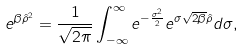<formula> <loc_0><loc_0><loc_500><loc_500>e ^ { \beta \hat { \rho } ^ { 2 } } = \frac { 1 } { \sqrt { 2 \pi } } \int _ { - \infty } ^ { \infty } e ^ { - \frac { \sigma ^ { 2 } } { 2 } } e ^ { \sigma \sqrt { 2 \beta } \hat { \rho } } d \sigma ,</formula> 